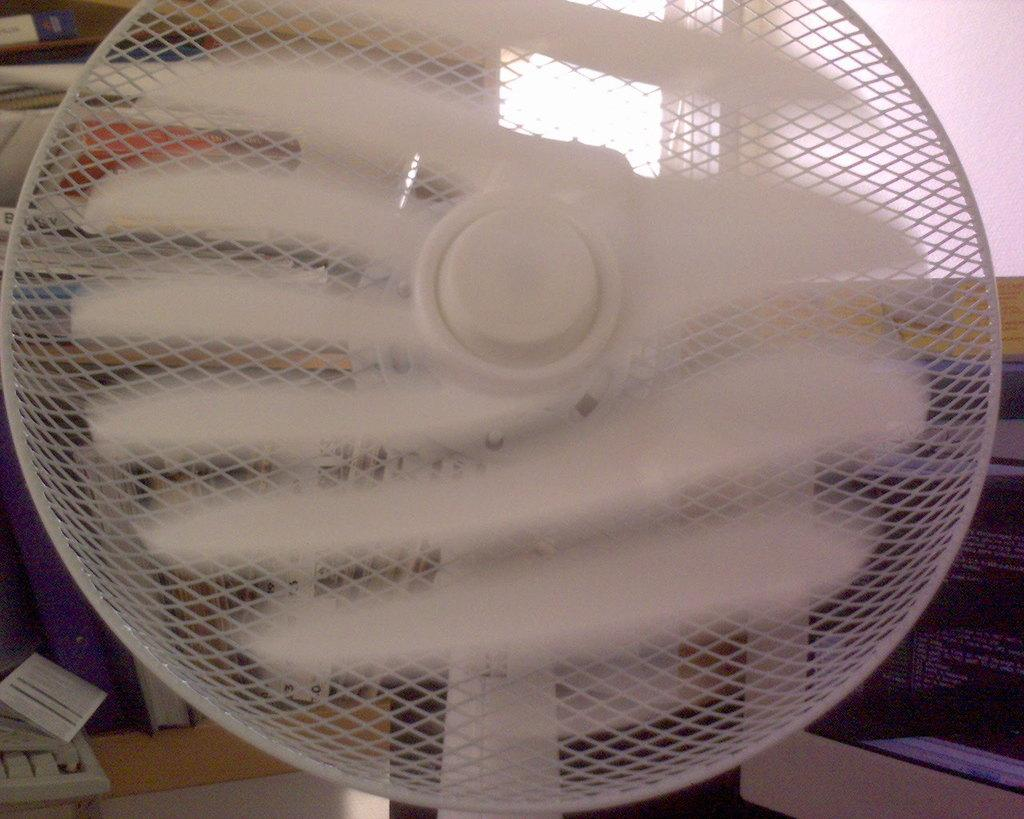What is located in the foreground of the image? There is a fan in the foreground of the image. What can be seen in the background of the image? There is a computer, a keyboard, a window, and a wall in the background of the image. What other objects are present in the background of the image? There are other objects present in the background of the image. How does the sail move in the image? There is no sail present in the image. How does the sail move in the image? There is no sail present in the image, so it is not possible to determine how it might move. 